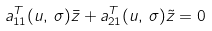Convert formula to latex. <formula><loc_0><loc_0><loc_500><loc_500>a _ { 1 1 } ^ { T } ( u , \, \sigma ) \bar { z } + a _ { 2 1 } ^ { T } ( u , \, \sigma ) \tilde { z } = 0</formula> 